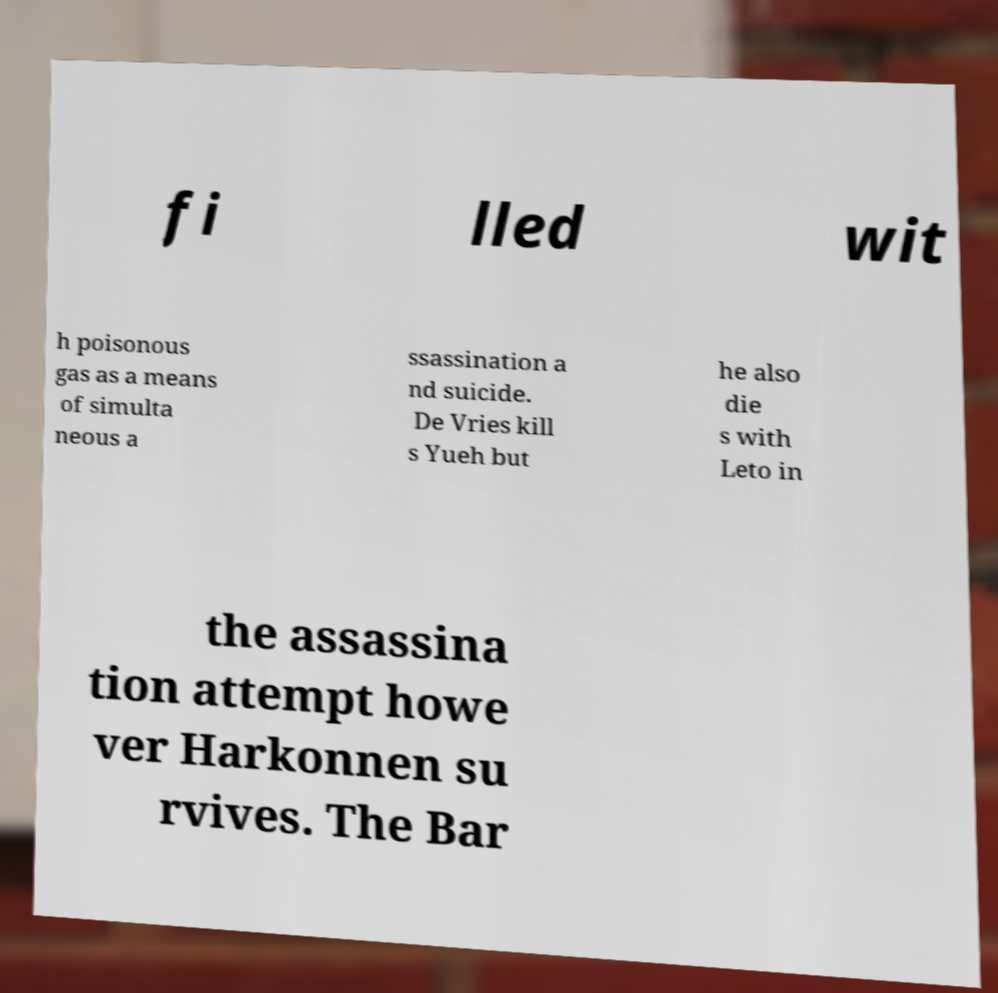Can you accurately transcribe the text from the provided image for me? fi lled wit h poisonous gas as a means of simulta neous a ssassination a nd suicide. De Vries kill s Yueh but he also die s with Leto in the assassina tion attempt howe ver Harkonnen su rvives. The Bar 